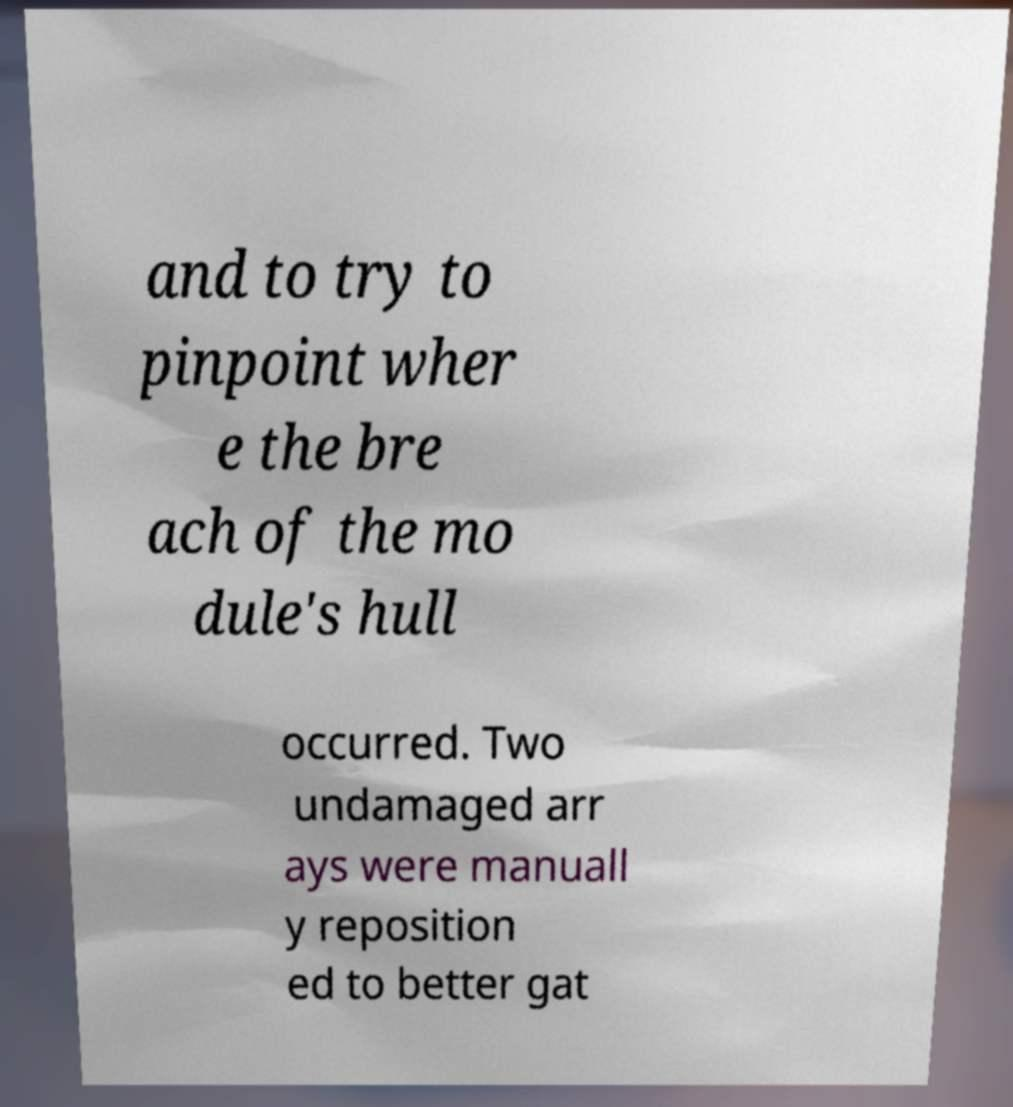Can you accurately transcribe the text from the provided image for me? and to try to pinpoint wher e the bre ach of the mo dule's hull occurred. Two undamaged arr ays were manuall y reposition ed to better gat 